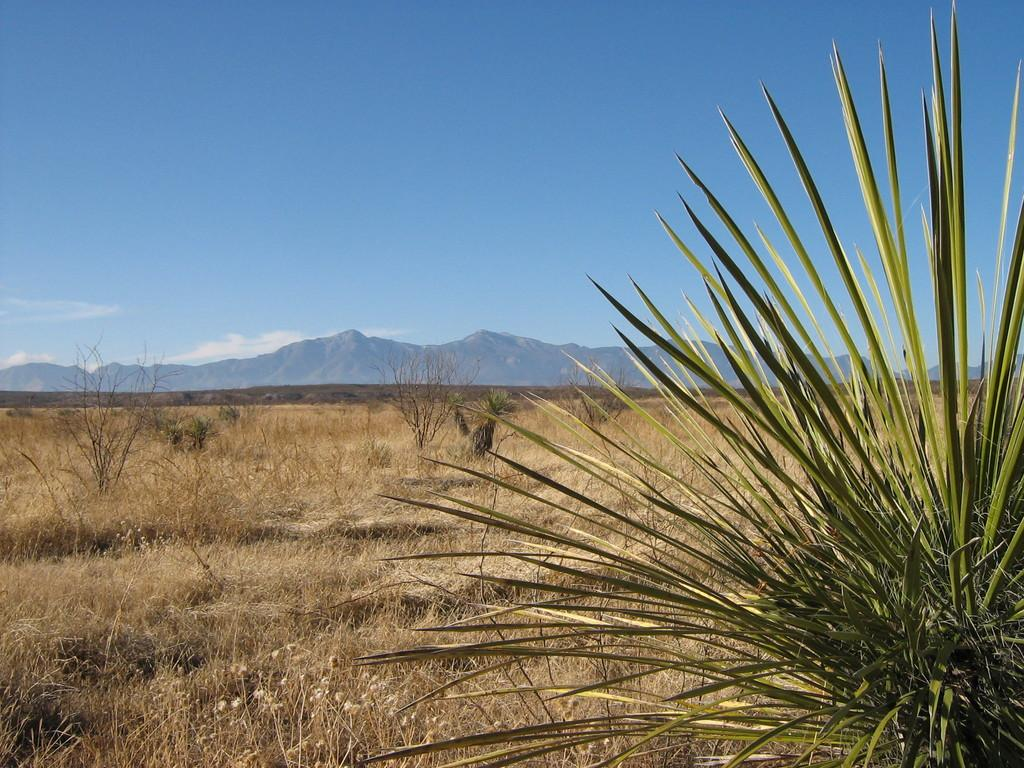What type of vegetation is present in the image? There is dry grass and plants in the image. What can be seen in the background of the image? There are trees in the background of the image. What is visible at the top of the image? The sky is visible at the top of the image. Where is the brass faucet located in the image? There is no brass faucet present in the image. What type of cake is being served in the image? There is no cake present in the image. 